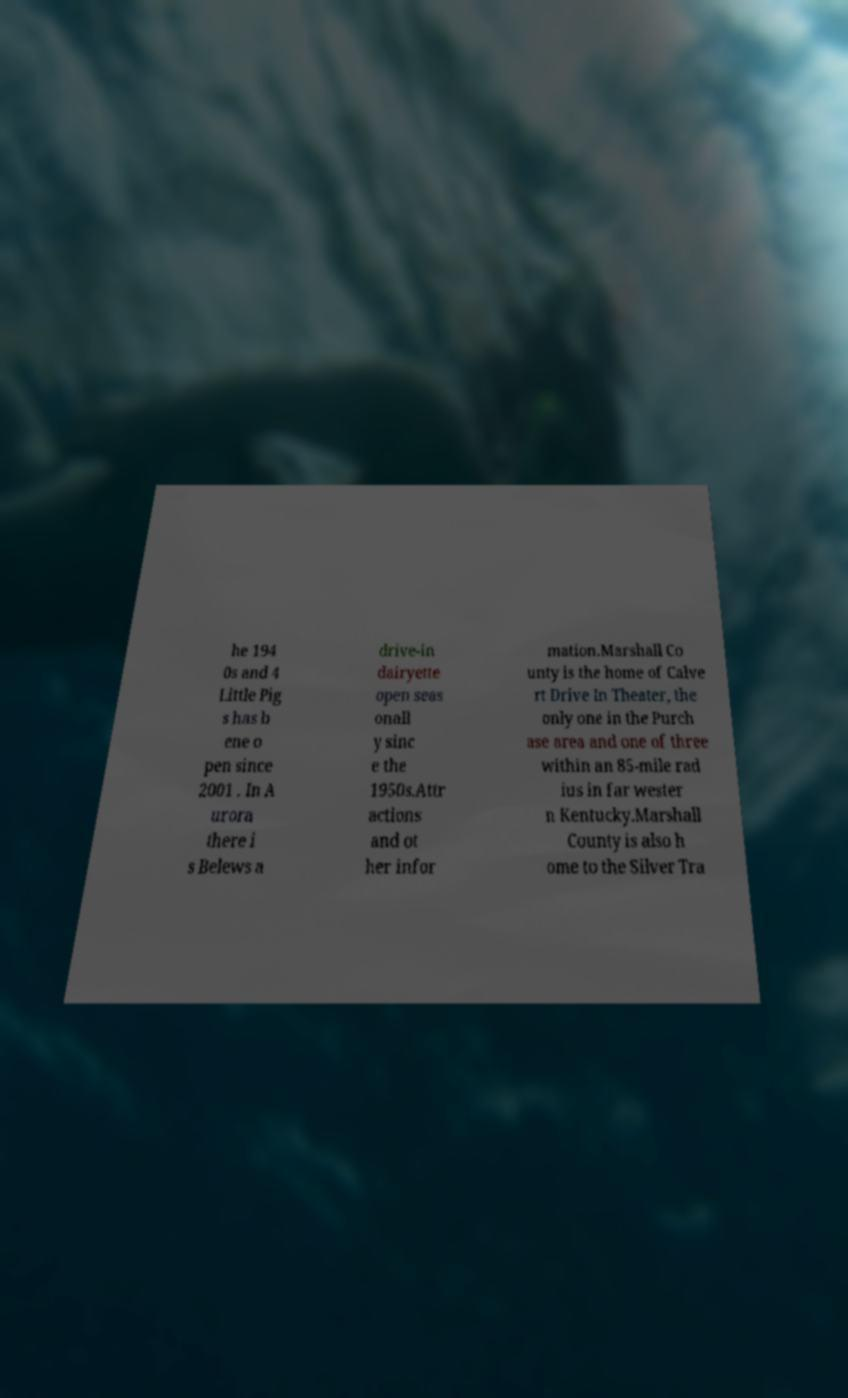Can you accurately transcribe the text from the provided image for me? he 194 0s and 4 Little Pig s has b ene o pen since 2001 . In A urora there i s Belews a drive-in dairyette open seas onall y sinc e the 1950s.Attr actions and ot her infor mation.Marshall Co unty is the home of Calve rt Drive In Theater, the only one in the Purch ase area and one of three within an 85-mile rad ius in far wester n Kentucky.Marshall County is also h ome to the Silver Tra 